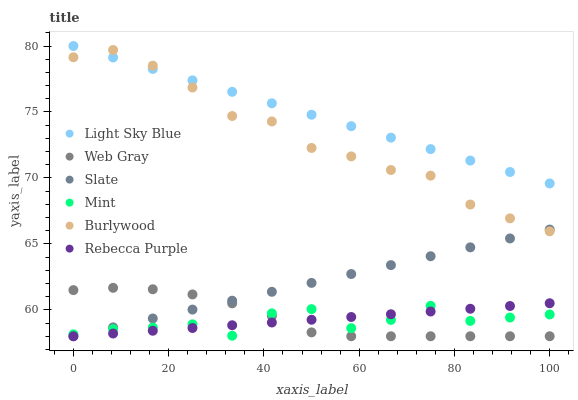Does Mint have the minimum area under the curve?
Answer yes or no. Yes. Does Light Sky Blue have the maximum area under the curve?
Answer yes or no. Yes. Does Burlywood have the minimum area under the curve?
Answer yes or no. No. Does Burlywood have the maximum area under the curve?
Answer yes or no. No. Is Light Sky Blue the smoothest?
Answer yes or no. Yes. Is Mint the roughest?
Answer yes or no. Yes. Is Burlywood the smoothest?
Answer yes or no. No. Is Burlywood the roughest?
Answer yes or no. No. Does Web Gray have the lowest value?
Answer yes or no. Yes. Does Burlywood have the lowest value?
Answer yes or no. No. Does Light Sky Blue have the highest value?
Answer yes or no. Yes. Does Burlywood have the highest value?
Answer yes or no. No. Is Rebecca Purple less than Burlywood?
Answer yes or no. Yes. Is Light Sky Blue greater than Rebecca Purple?
Answer yes or no. Yes. Does Web Gray intersect Mint?
Answer yes or no. Yes. Is Web Gray less than Mint?
Answer yes or no. No. Is Web Gray greater than Mint?
Answer yes or no. No. Does Rebecca Purple intersect Burlywood?
Answer yes or no. No. 